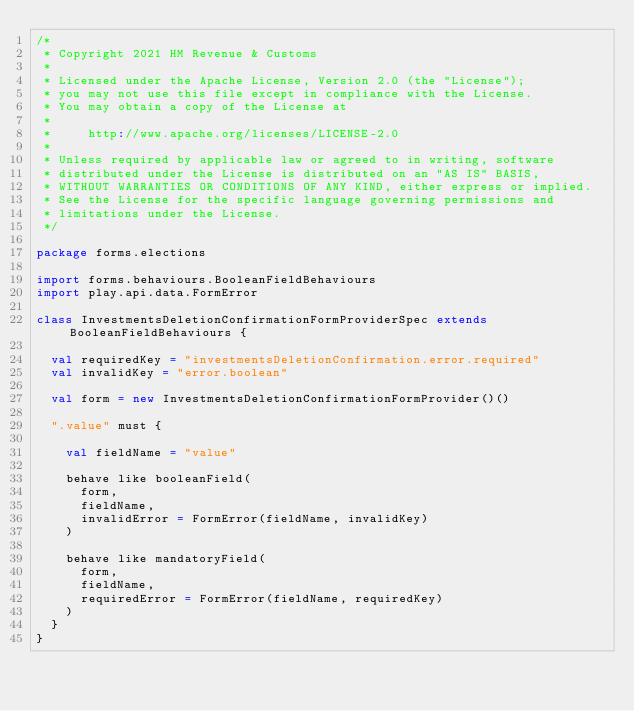Convert code to text. <code><loc_0><loc_0><loc_500><loc_500><_Scala_>/*
 * Copyright 2021 HM Revenue & Customs
 *
 * Licensed under the Apache License, Version 2.0 (the "License");
 * you may not use this file except in compliance with the License.
 * You may obtain a copy of the License at
 *
 *     http://www.apache.org/licenses/LICENSE-2.0
 *
 * Unless required by applicable law or agreed to in writing, software
 * distributed under the License is distributed on an "AS IS" BASIS,
 * WITHOUT WARRANTIES OR CONDITIONS OF ANY KIND, either express or implied.
 * See the License for the specific language governing permissions and
 * limitations under the License.
 */

package forms.elections

import forms.behaviours.BooleanFieldBehaviours
import play.api.data.FormError

class InvestmentsDeletionConfirmationFormProviderSpec extends BooleanFieldBehaviours {

  val requiredKey = "investmentsDeletionConfirmation.error.required"
  val invalidKey = "error.boolean"

  val form = new InvestmentsDeletionConfirmationFormProvider()()

  ".value" must {

    val fieldName = "value"

    behave like booleanField(
      form,
      fieldName,
      invalidError = FormError(fieldName, invalidKey)
    )

    behave like mandatoryField(
      form,
      fieldName,
      requiredError = FormError(fieldName, requiredKey)
    )
  }
}
</code> 